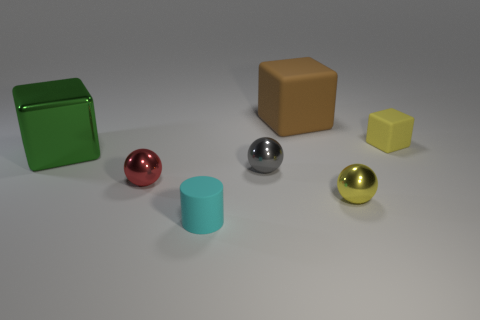Subtract all rubber blocks. How many blocks are left? 1 Subtract 1 spheres. How many spheres are left? 2 Add 3 large cyan metal cubes. How many objects exist? 10 Subtract all brown spheres. Subtract all gray cubes. How many spheres are left? 3 Subtract all blocks. How many objects are left? 4 Subtract all tiny blue matte balls. Subtract all tiny cyan matte objects. How many objects are left? 6 Add 2 metal cubes. How many metal cubes are left? 3 Add 1 gray metallic balls. How many gray metallic balls exist? 2 Subtract 0 brown spheres. How many objects are left? 7 